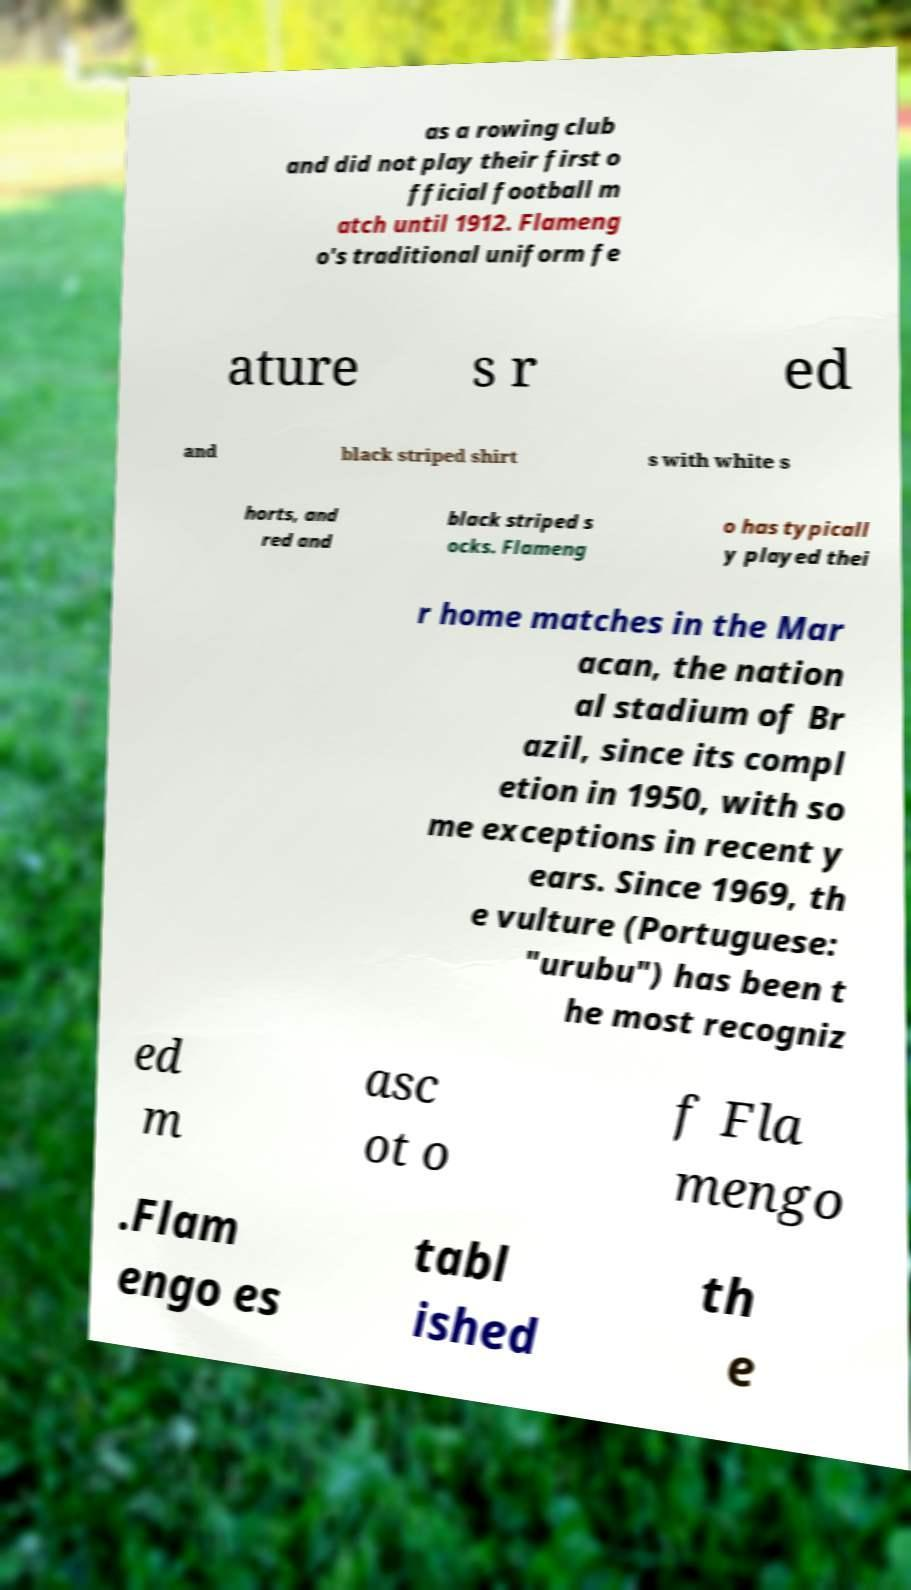Could you extract and type out the text from this image? as a rowing club and did not play their first o fficial football m atch until 1912. Flameng o's traditional uniform fe ature s r ed and black striped shirt s with white s horts, and red and black striped s ocks. Flameng o has typicall y played thei r home matches in the Mar acan, the nation al stadium of Br azil, since its compl etion in 1950, with so me exceptions in recent y ears. Since 1969, th e vulture (Portuguese: "urubu") has been t he most recogniz ed m asc ot o f Fla mengo .Flam engo es tabl ished th e 